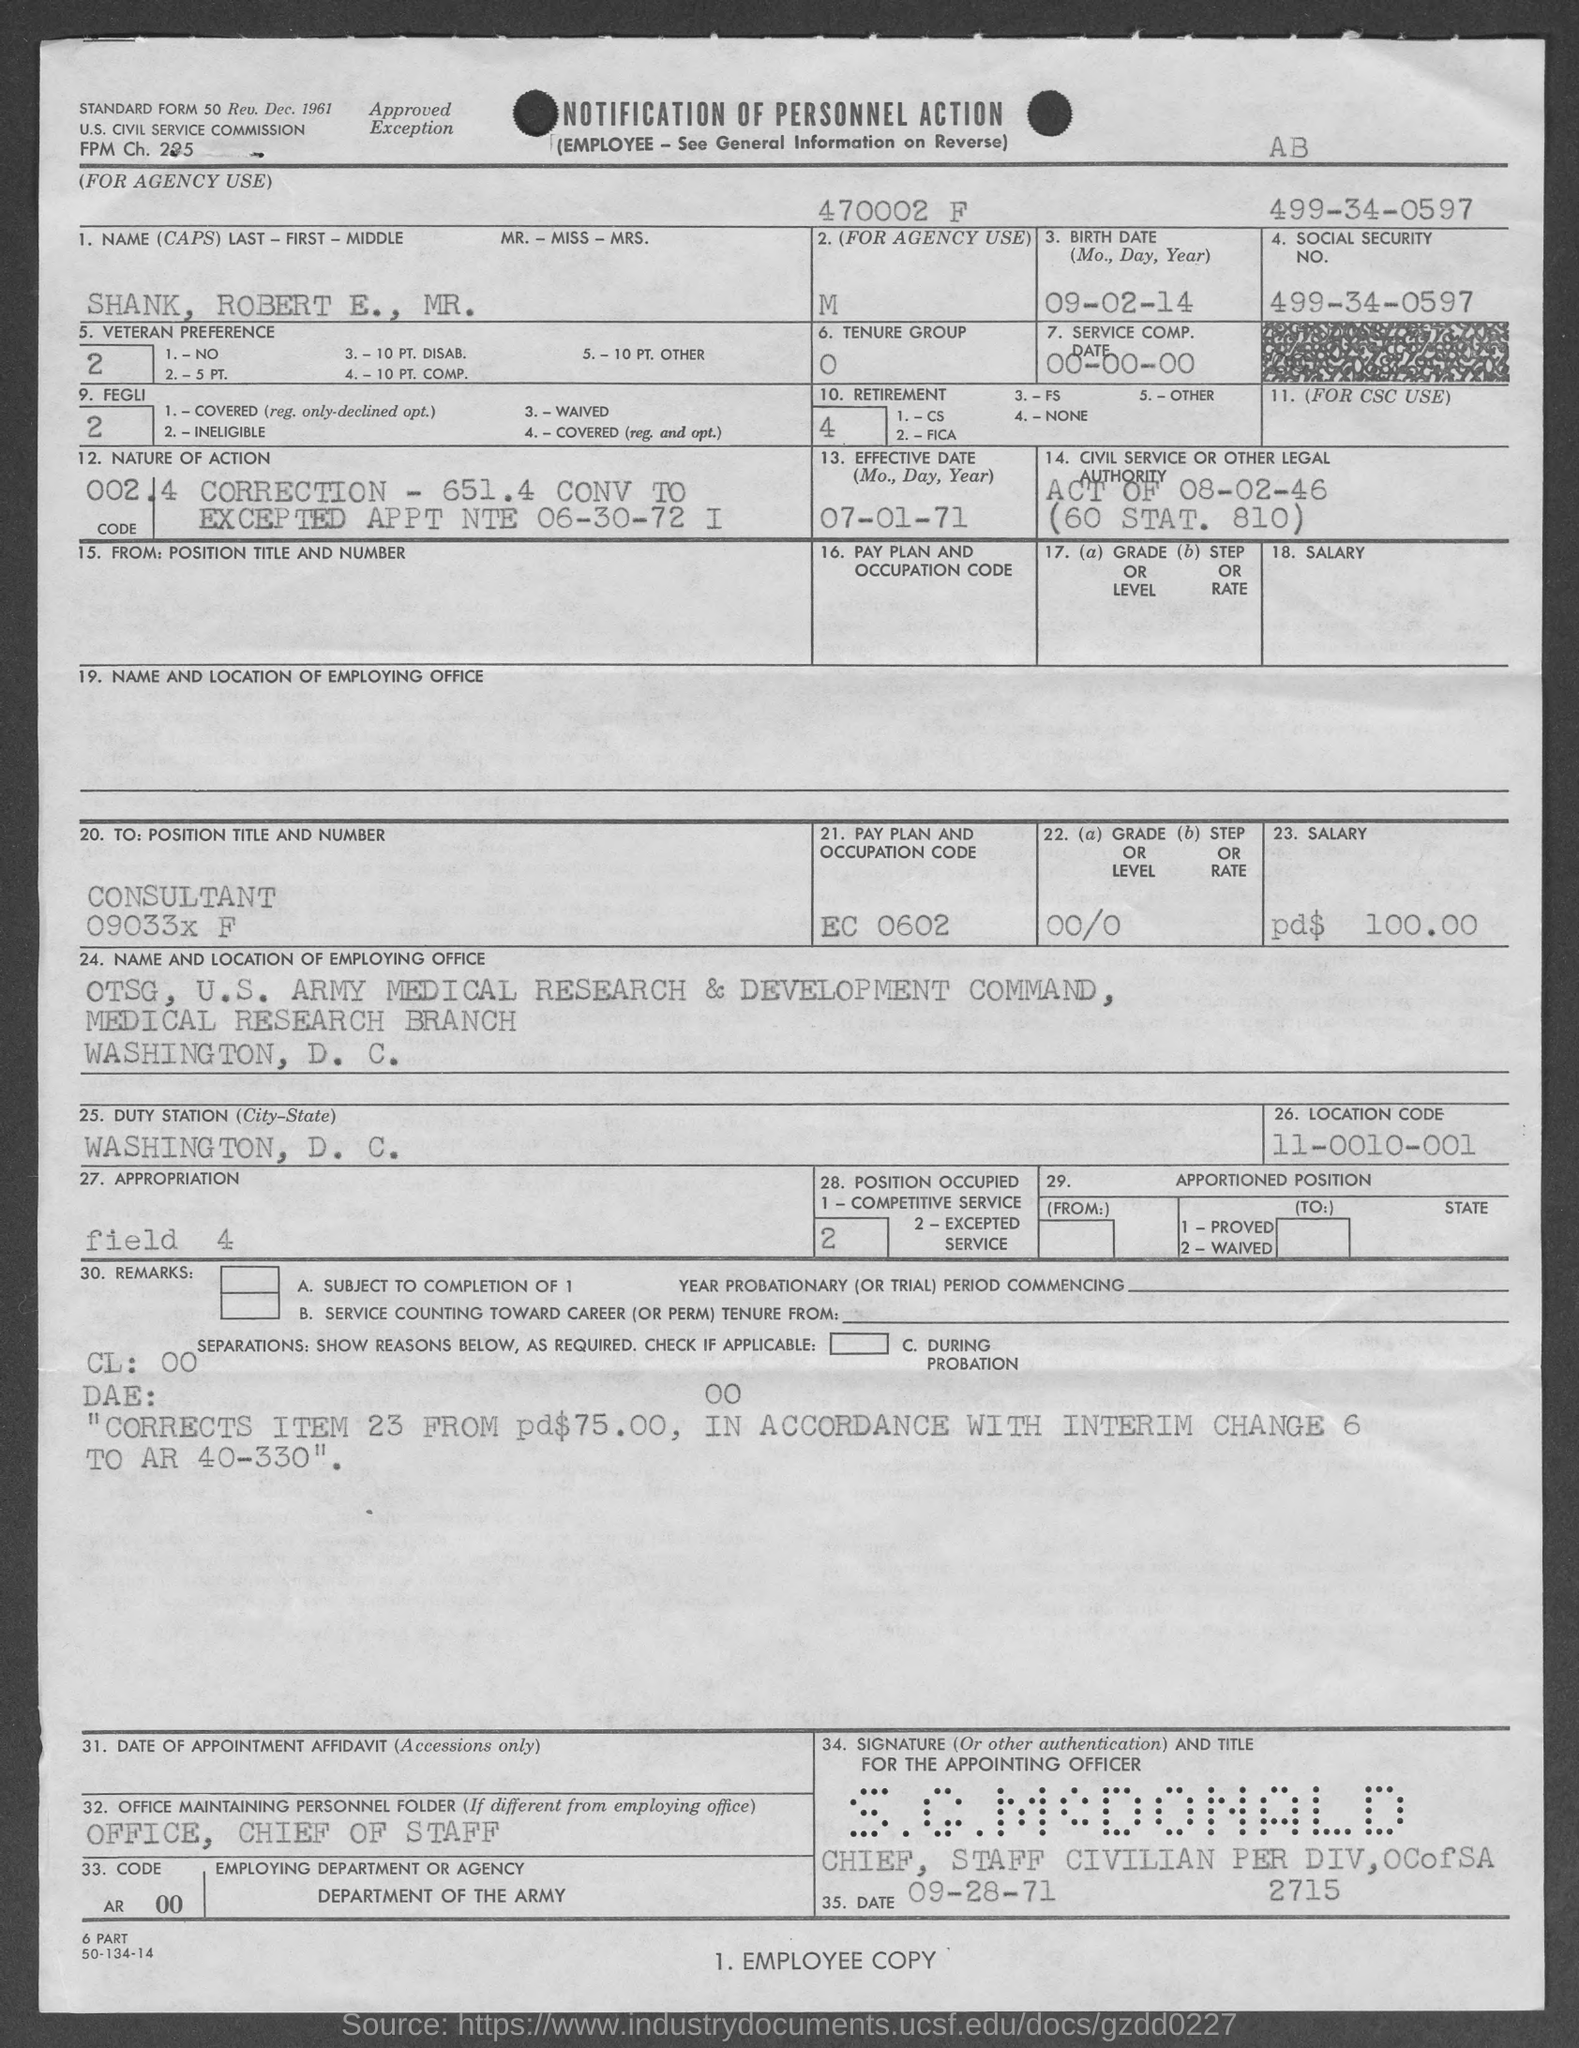What is the location code?
Provide a succinct answer. 11-0010-001. What is the pay plan and occupaton code ?
Make the answer very short. EC 0602. What is the social security no.?
Provide a short and direct response. 499-34-0597. What is the birth date of candidate ?
Make the answer very short. 09-02-14. 